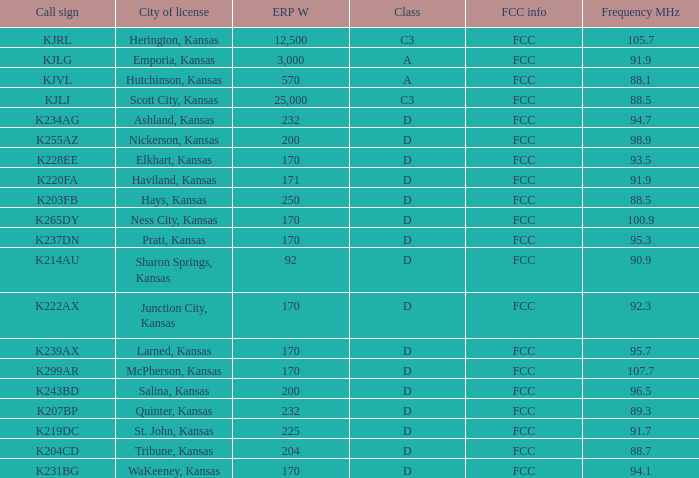Call sign of k231bg has what sum of erp w? 170.0. 